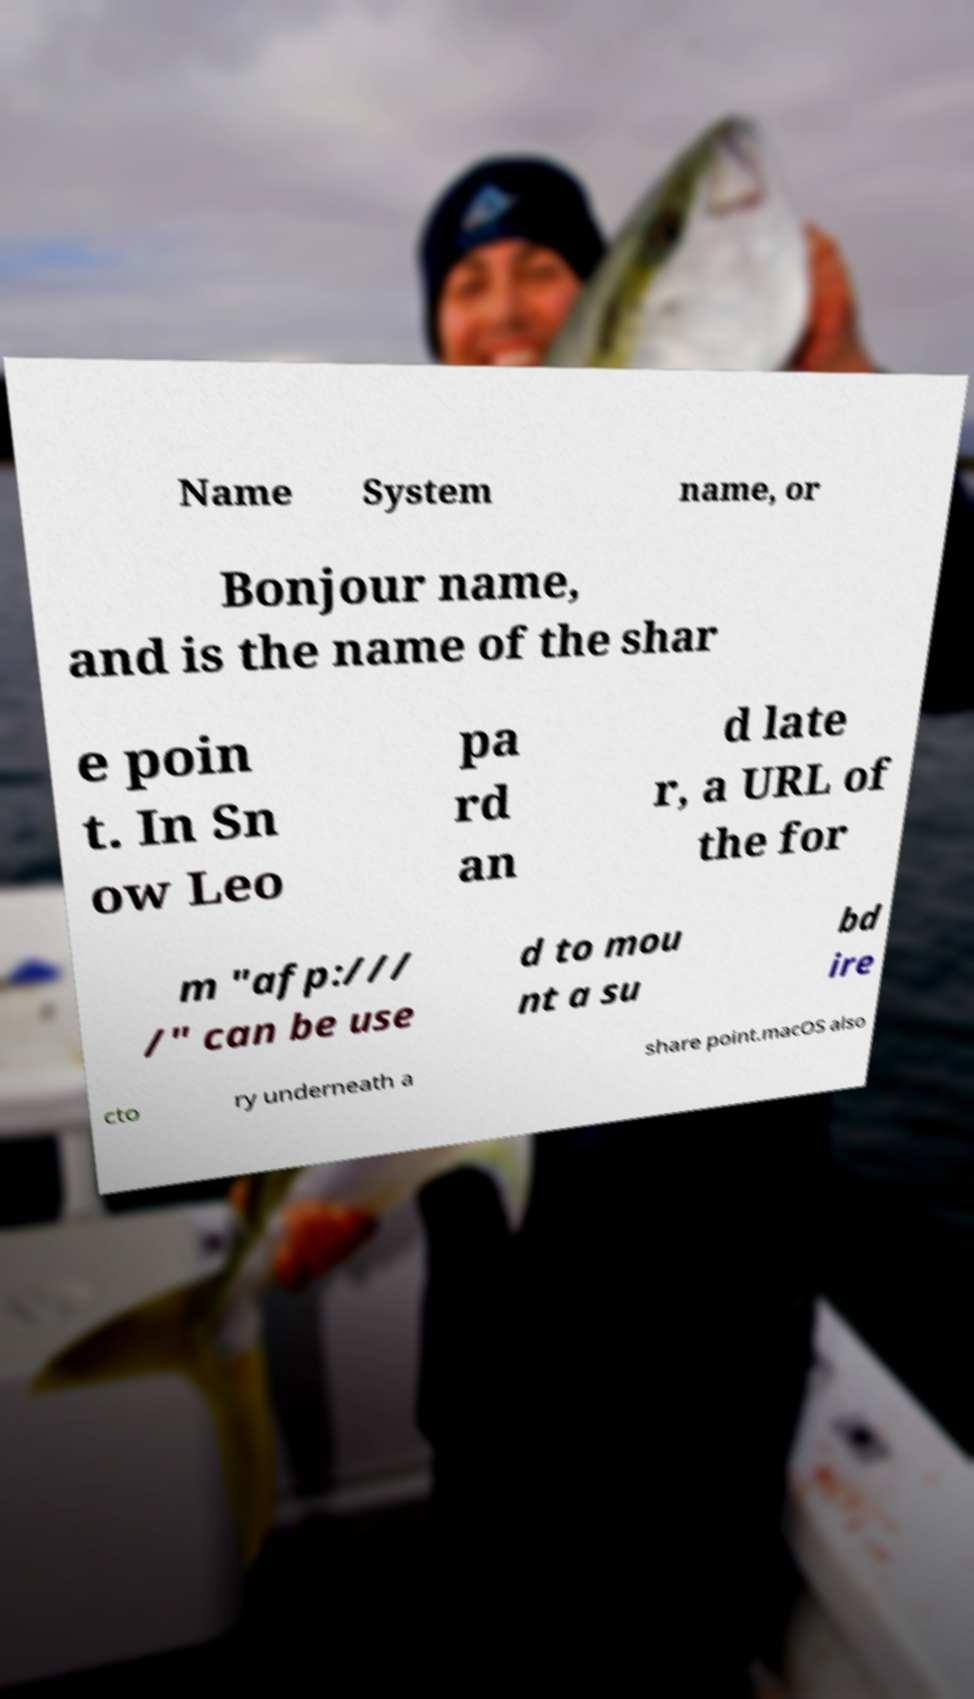Please read and relay the text visible in this image. What does it say? Name System name, or Bonjour name, and is the name of the shar e poin t. In Sn ow Leo pa rd an d late r, a URL of the for m "afp:/// /" can be use d to mou nt a su bd ire cto ry underneath a share point.macOS also 